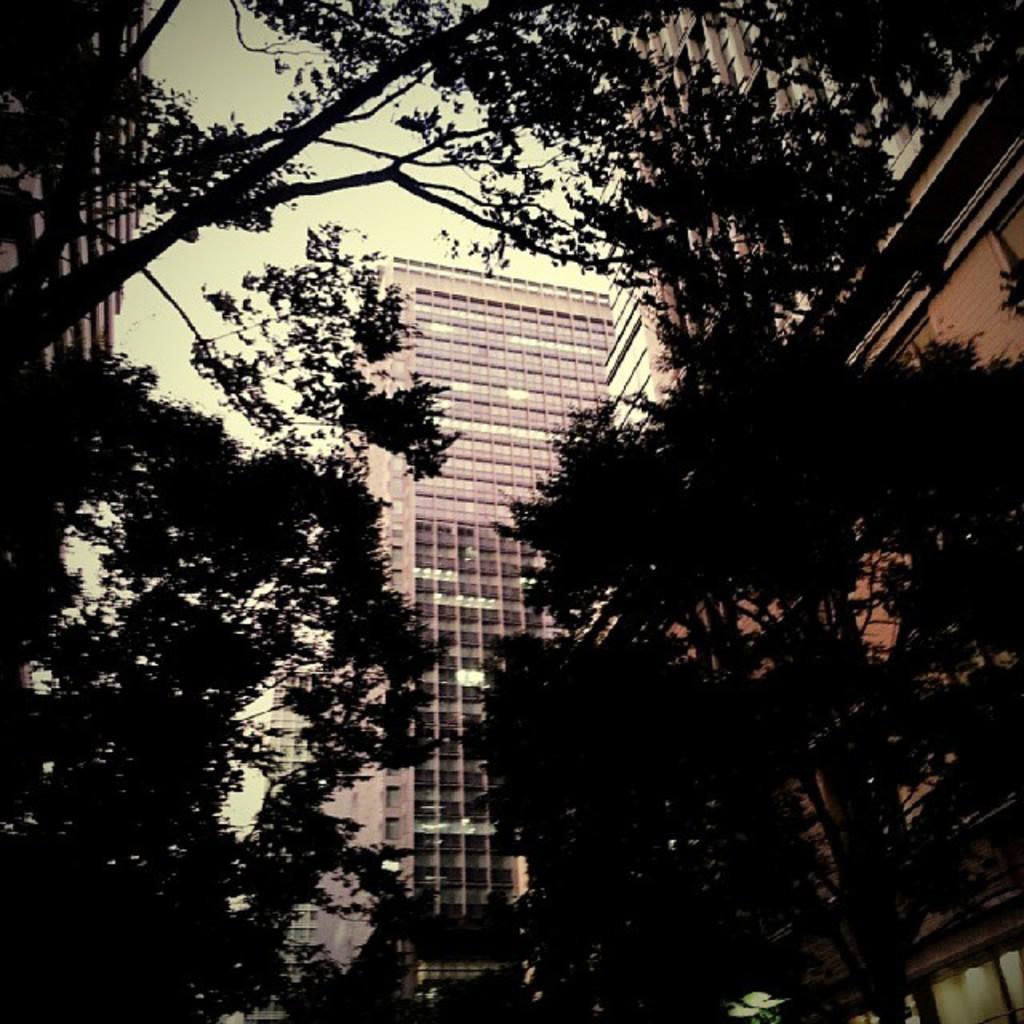Could you give a brief overview of what you see in this image? In this picture we can see a few trees and buildings in the background. 